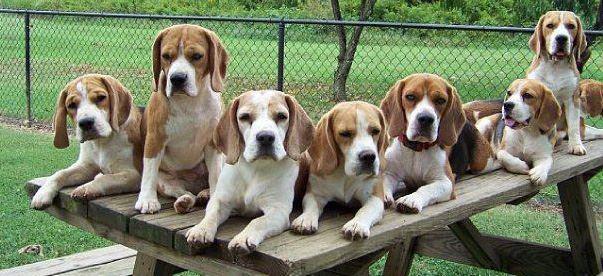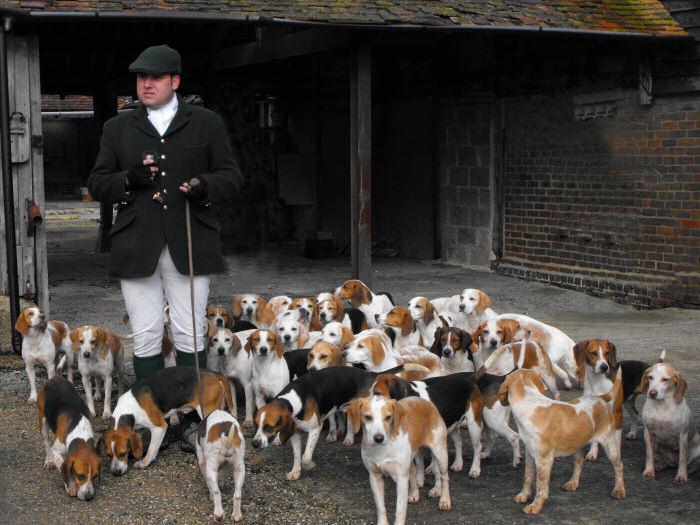The first image is the image on the left, the second image is the image on the right. For the images displayed, is the sentence "There is one person standing in the image on the right." factually correct? Answer yes or no. Yes. The first image is the image on the left, the second image is the image on the right. Evaluate the accuracy of this statement regarding the images: "Both photos show dogs running in the grass.". Is it true? Answer yes or no. No. The first image is the image on the left, the second image is the image on the right. Analyze the images presented: Is the assertion "There is a person standing among several dogs in the image on the right." valid? Answer yes or no. Yes. 